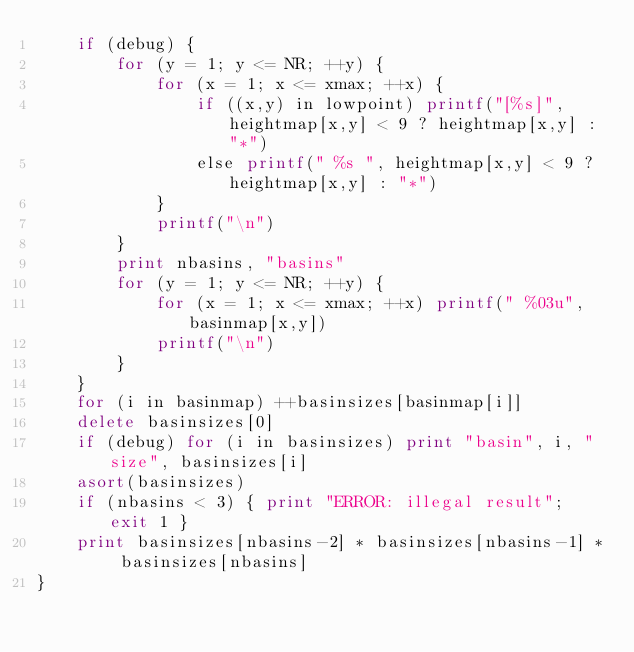<code> <loc_0><loc_0><loc_500><loc_500><_Awk_>    if (debug) {
        for (y = 1; y <= NR; ++y) {
            for (x = 1; x <= xmax; ++x) {
                if ((x,y) in lowpoint) printf("[%s]", heightmap[x,y] < 9 ? heightmap[x,y] : "*")
                else printf(" %s ", heightmap[x,y] < 9 ? heightmap[x,y] : "*")
            }
            printf("\n")
        }
        print nbasins, "basins"
        for (y = 1; y <= NR; ++y) {
            for (x = 1; x <= xmax; ++x) printf(" %03u", basinmap[x,y])
            printf("\n")
        }
    }
    for (i in basinmap) ++basinsizes[basinmap[i]]
    delete basinsizes[0]
    if (debug) for (i in basinsizes) print "basin", i, "size", basinsizes[i]
    asort(basinsizes)
    if (nbasins < 3) { print "ERROR: illegal result"; exit 1 }
    print basinsizes[nbasins-2] * basinsizes[nbasins-1] * basinsizes[nbasins]
}
</code> 